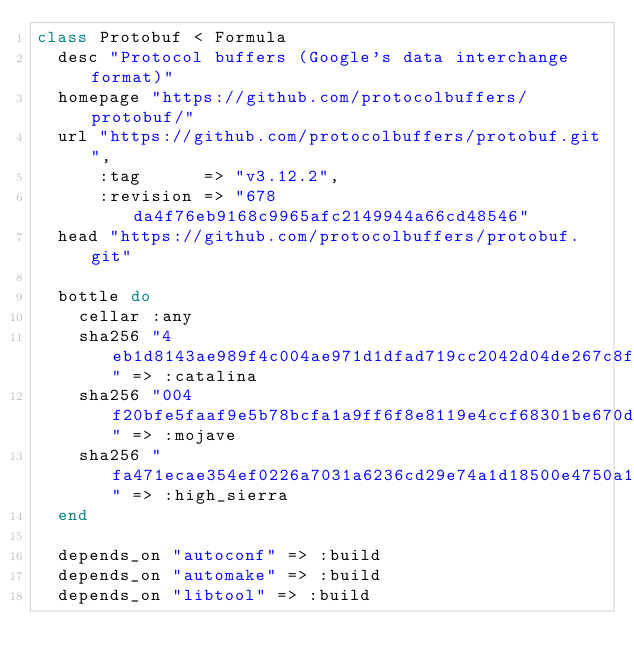Convert code to text. <code><loc_0><loc_0><loc_500><loc_500><_Ruby_>class Protobuf < Formula
  desc "Protocol buffers (Google's data interchange format)"
  homepage "https://github.com/protocolbuffers/protobuf/"
  url "https://github.com/protocolbuffers/protobuf.git",
      :tag      => "v3.12.2",
      :revision => "678da4f76eb9168c9965afc2149944a66cd48546"
  head "https://github.com/protocolbuffers/protobuf.git"

  bottle do
    cellar :any
    sha256 "4eb1d8143ae989f4c004ae971d1dfad719cc2042d04de267c8fca3193f9cfd71" => :catalina
    sha256 "004f20bfe5faaf9e5b78bcfa1a9ff6f8e8119e4ccf68301be670dd0c8cf8280e" => :mojave
    sha256 "fa471ecae354ef0226a7031a6236cd29e74a1d18500e4750a19e6ad3327fce46" => :high_sierra
  end

  depends_on "autoconf" => :build
  depends_on "automake" => :build
  depends_on "libtool" => :build</code> 